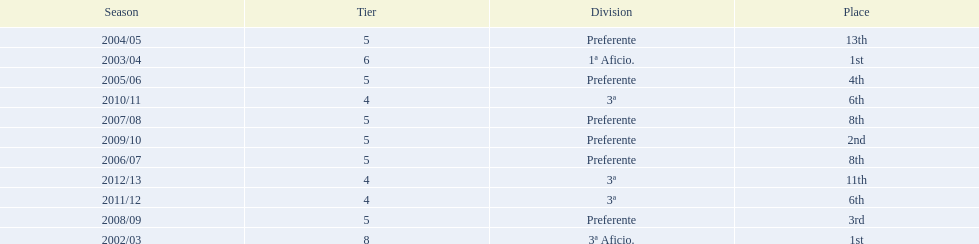How many times did  internacional de madrid cf come in 6th place? 6th, 6th. What is the first season that the team came in 6th place? 2010/11. Which season after the first did they place in 6th again? 2011/12. 